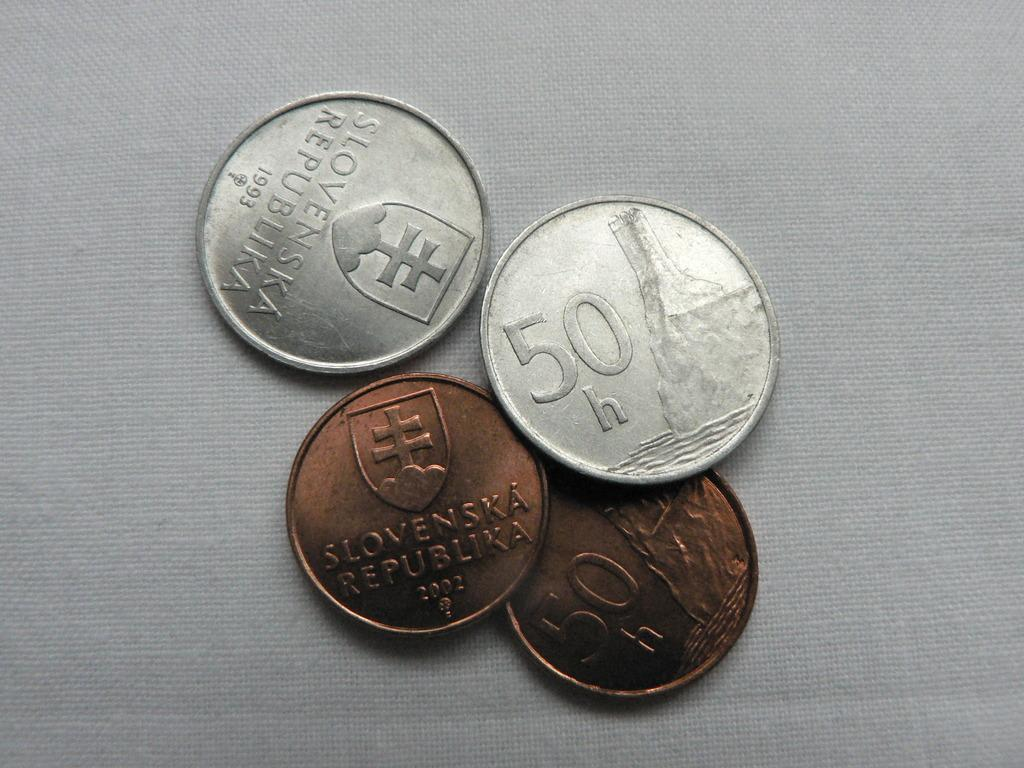<image>
Provide a brief description of the given image. coins from slkvenska repuclina of different metals for 50h 